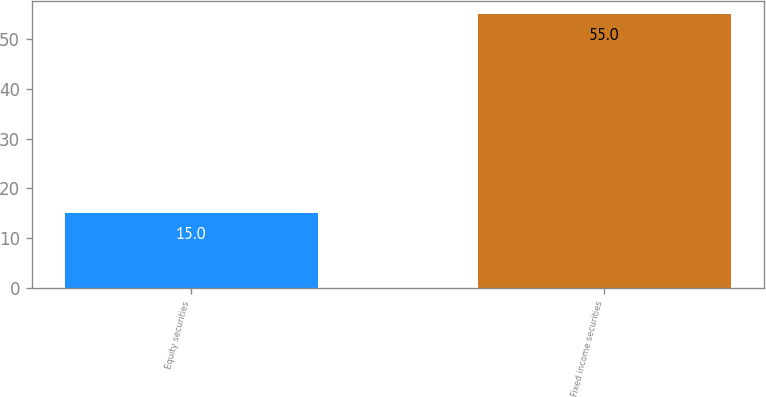Convert chart. <chart><loc_0><loc_0><loc_500><loc_500><bar_chart><fcel>Equity securities<fcel>Fixed income securities<nl><fcel>15<fcel>55<nl></chart> 